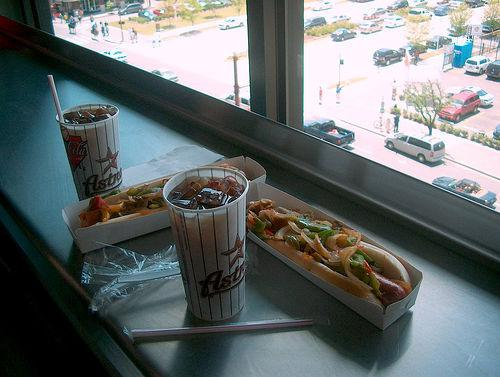What food is shown in the boats? Please explain your reasoning. hot dog. There are some hot dogs on top of the counter. 